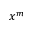<formula> <loc_0><loc_0><loc_500><loc_500>x ^ { m }</formula> 